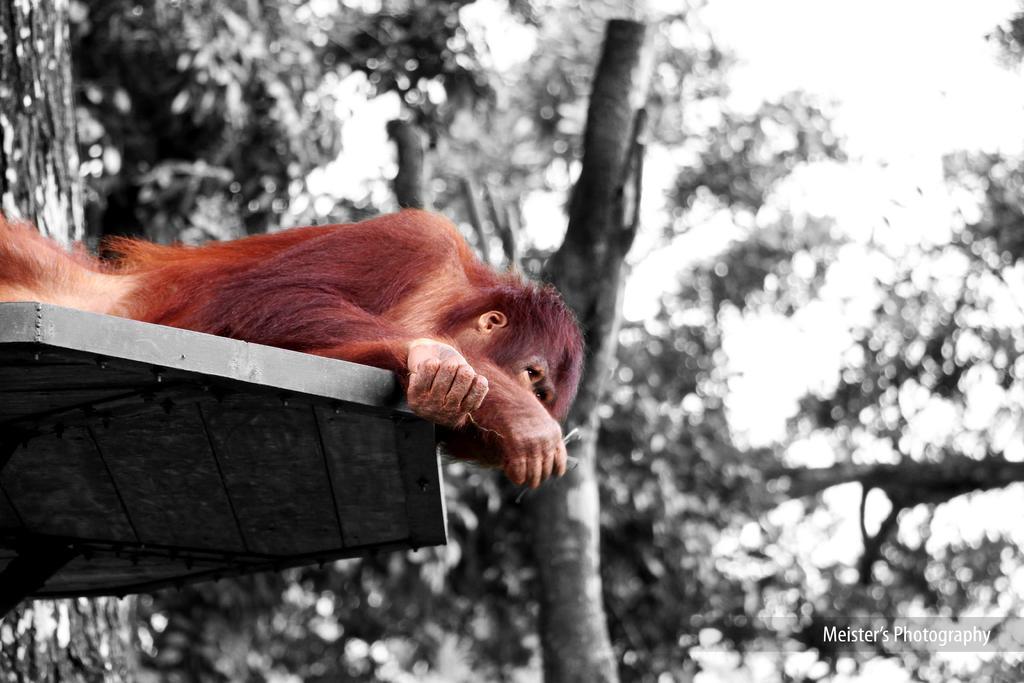Can you describe this image briefly? In this picture I can see a monkey which is of reddish brown color and it is on a thing. In the background I can see the trees and I see that it is blurred. On the bottom right corner of this picture I can see the watermark. 